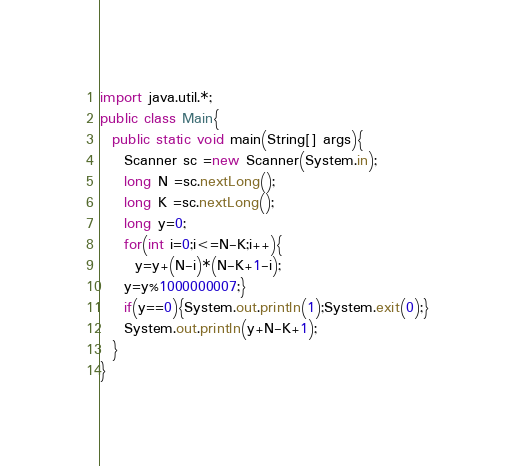<code> <loc_0><loc_0><loc_500><loc_500><_Java_>import java.util.*;
public class Main{
  public static void main(String[] args){
    Scanner sc =new Scanner(System.in);
    long N =sc.nextLong();
    long K =sc.nextLong();
    long y=0;
    for(int i=0;i<=N-K;i++){
      y=y+(N-i)*(N-K+1-i);
    y=y%1000000007;}
    if(y==0){System.out.println(1);System.exit(0);}
    System.out.println(y+N-K+1);
  }
}
</code> 